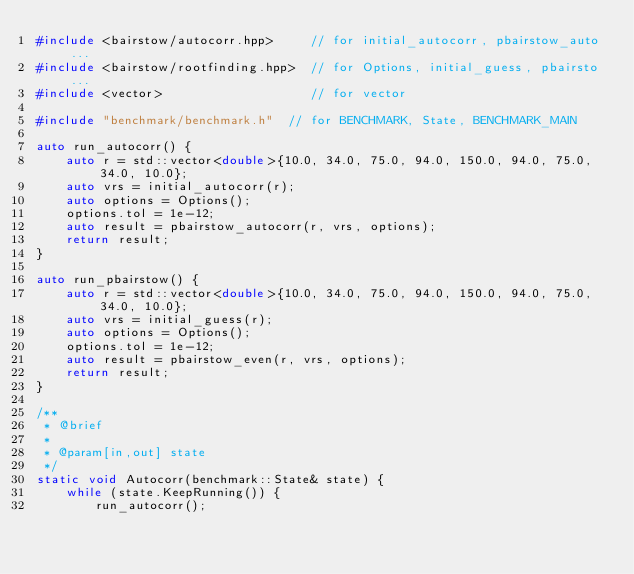<code> <loc_0><loc_0><loc_500><loc_500><_C++_>#include <bairstow/autocorr.hpp>     // for initial_autocorr, pbairstow_auto...
#include <bairstow/rootfinding.hpp>  // for Options, initial_guess, pbairsto...
#include <vector>                    // for vector

#include "benchmark/benchmark.h"  // for BENCHMARK, State, BENCHMARK_MAIN

auto run_autocorr() {
    auto r = std::vector<double>{10.0, 34.0, 75.0, 94.0, 150.0, 94.0, 75.0, 34.0, 10.0};
    auto vrs = initial_autocorr(r);
    auto options = Options();
    options.tol = 1e-12;
    auto result = pbairstow_autocorr(r, vrs, options);
    return result;
}

auto run_pbairstow() {
    auto r = std::vector<double>{10.0, 34.0, 75.0, 94.0, 150.0, 94.0, 75.0, 34.0, 10.0};
    auto vrs = initial_guess(r);
    auto options = Options();
    options.tol = 1e-12;
    auto result = pbairstow_even(r, vrs, options);
    return result;
}

/**
 * @brief
 *
 * @param[in,out] state
 */
static void Autocorr(benchmark::State& state) {
    while (state.KeepRunning()) {
        run_autocorr();</code> 